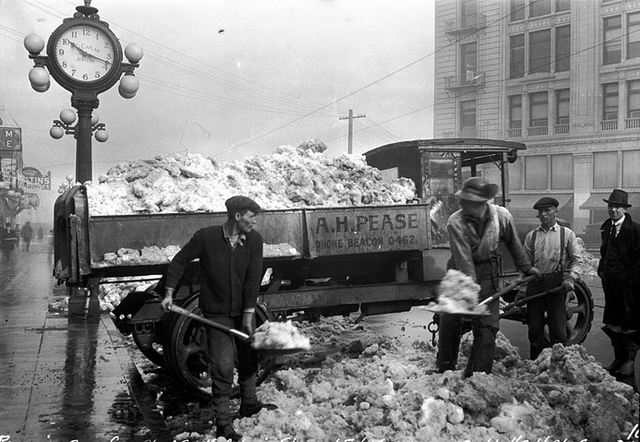Please extract the text content from this image. 9 A H PEASE PHONE BEACON 0462 6 M 2 1 12 11 10 3 4 5 6 7 8 